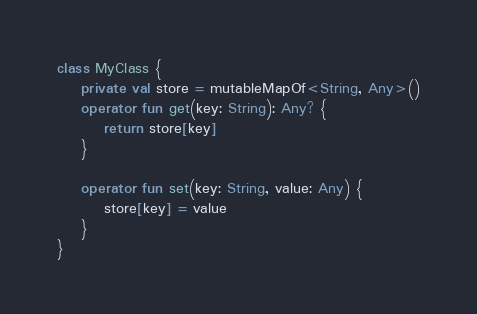<code> <loc_0><loc_0><loc_500><loc_500><_Kotlin_>class MyClass {
    private val store = mutableMapOf<String, Any>()
    operator fun get(key: String): Any? {
        return store[key]
    }

    operator fun set(key: String, value: Any) {
        store[key] = value
    }
}
</code> 